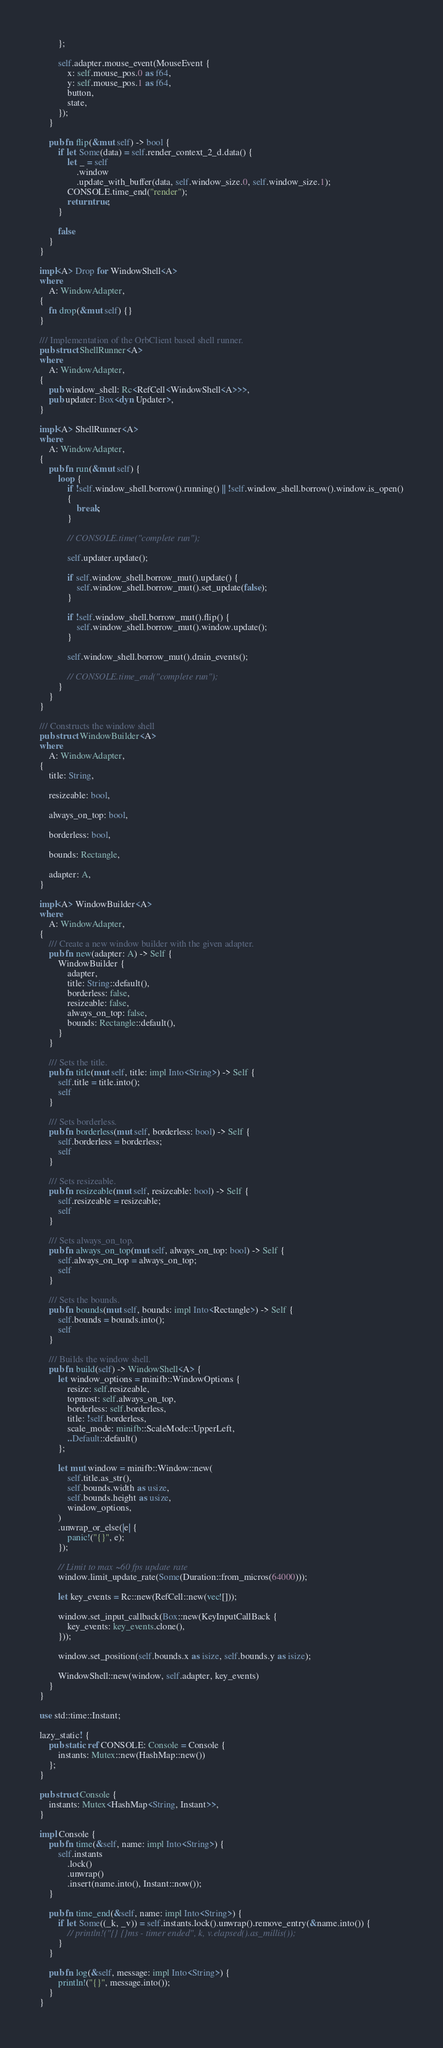<code> <loc_0><loc_0><loc_500><loc_500><_Rust_>        };

        self.adapter.mouse_event(MouseEvent {
            x: self.mouse_pos.0 as f64,
            y: self.mouse_pos.1 as f64,
            button,
            state,
        });
    }

    pub fn flip(&mut self) -> bool {
        if let Some(data) = self.render_context_2_d.data() {
            let _ = self
                .window
                .update_with_buffer(data, self.window_size.0, self.window_size.1);
            CONSOLE.time_end("render");
            return true;
        }

        false
    }
}

impl<A> Drop for WindowShell<A>
where
    A: WindowAdapter,
{
    fn drop(&mut self) {}
}

/// Implementation of the OrbClient based shell runner.
pub struct ShellRunner<A>
where
    A: WindowAdapter,
{
    pub window_shell: Rc<RefCell<WindowShell<A>>>,
    pub updater: Box<dyn Updater>,
}

impl<A> ShellRunner<A>
where
    A: WindowAdapter,
{
    pub fn run(&mut self) {
        loop {
            if !self.window_shell.borrow().running() || !self.window_shell.borrow().window.is_open()
            {
                break;
            }

            // CONSOLE.time("complete run");

            self.updater.update();

            if self.window_shell.borrow_mut().update() {
                self.window_shell.borrow_mut().set_update(false);
            }

            if !self.window_shell.borrow_mut().flip() {
                self.window_shell.borrow_mut().window.update();
            }

            self.window_shell.borrow_mut().drain_events();

            // CONSOLE.time_end("complete run");
        }
    }
}

/// Constructs the window shell
pub struct WindowBuilder<A>
where
    A: WindowAdapter,
{
    title: String,

    resizeable: bool,

    always_on_top: bool,

    borderless: bool,

    bounds: Rectangle,

    adapter: A,
}

impl<A> WindowBuilder<A>
where
    A: WindowAdapter,
{
    /// Create a new window builder with the given adapter.
    pub fn new(adapter: A) -> Self {
        WindowBuilder {
            adapter,
            title: String::default(),
            borderless: false,
            resizeable: false,
            always_on_top: false,
            bounds: Rectangle::default(),
        }
    }

    /// Sets the title.
    pub fn title(mut self, title: impl Into<String>) -> Self {
        self.title = title.into();
        self
    }

    /// Sets borderless.
    pub fn borderless(mut self, borderless: bool) -> Self {
        self.borderless = borderless;
        self
    }

    /// Sets resizeable.
    pub fn resizeable(mut self, resizeable: bool) -> Self {
        self.resizeable = resizeable;
        self
    }

    /// Sets always_on_top.
    pub fn always_on_top(mut self, always_on_top: bool) -> Self {
        self.always_on_top = always_on_top;
        self
    }

    /// Sets the bounds.
    pub fn bounds(mut self, bounds: impl Into<Rectangle>) -> Self {
        self.bounds = bounds.into();
        self
    }

    /// Builds the window shell.
    pub fn build(self) -> WindowShell<A> {
        let window_options = minifb::WindowOptions {
            resize: self.resizeable,
            topmost: self.always_on_top,
            borderless: self.borderless,
            title: !self.borderless,
            scale_mode: minifb::ScaleMode::UpperLeft,
            ..Default::default()
        };

        let mut window = minifb::Window::new(
            self.title.as_str(),
            self.bounds.width as usize,
            self.bounds.height as usize,
            window_options,
        )
        .unwrap_or_else(|e| {
            panic!("{}", e);
        });

        // Limit to max ~60 fps update rate
        window.limit_update_rate(Some(Duration::from_micros(64000)));

        let key_events = Rc::new(RefCell::new(vec![]));

        window.set_input_callback(Box::new(KeyInputCallBack {
            key_events: key_events.clone(),
        }));

        window.set_position(self.bounds.x as isize, self.bounds.y as isize);

        WindowShell::new(window, self.adapter, key_events)
    }
}

use std::time::Instant;

lazy_static! {
    pub static ref CONSOLE: Console = Console {
        instants: Mutex::new(HashMap::new())
    };
}

pub struct Console {
    instants: Mutex<HashMap<String, Instant>>,
}

impl Console {
    pub fn time(&self, name: impl Into<String>) {
        self.instants
            .lock()
            .unwrap()
            .insert(name.into(), Instant::now());
    }

    pub fn time_end(&self, name: impl Into<String>) {
        if let Some((_k, _v)) = self.instants.lock().unwrap().remove_entry(&name.into()) {
            // println!("{} {}ms - timer ended", k, v.elapsed().as_millis());
        }
    }

    pub fn log(&self, message: impl Into<String>) {
        println!("{}", message.into());
    }
}
</code> 